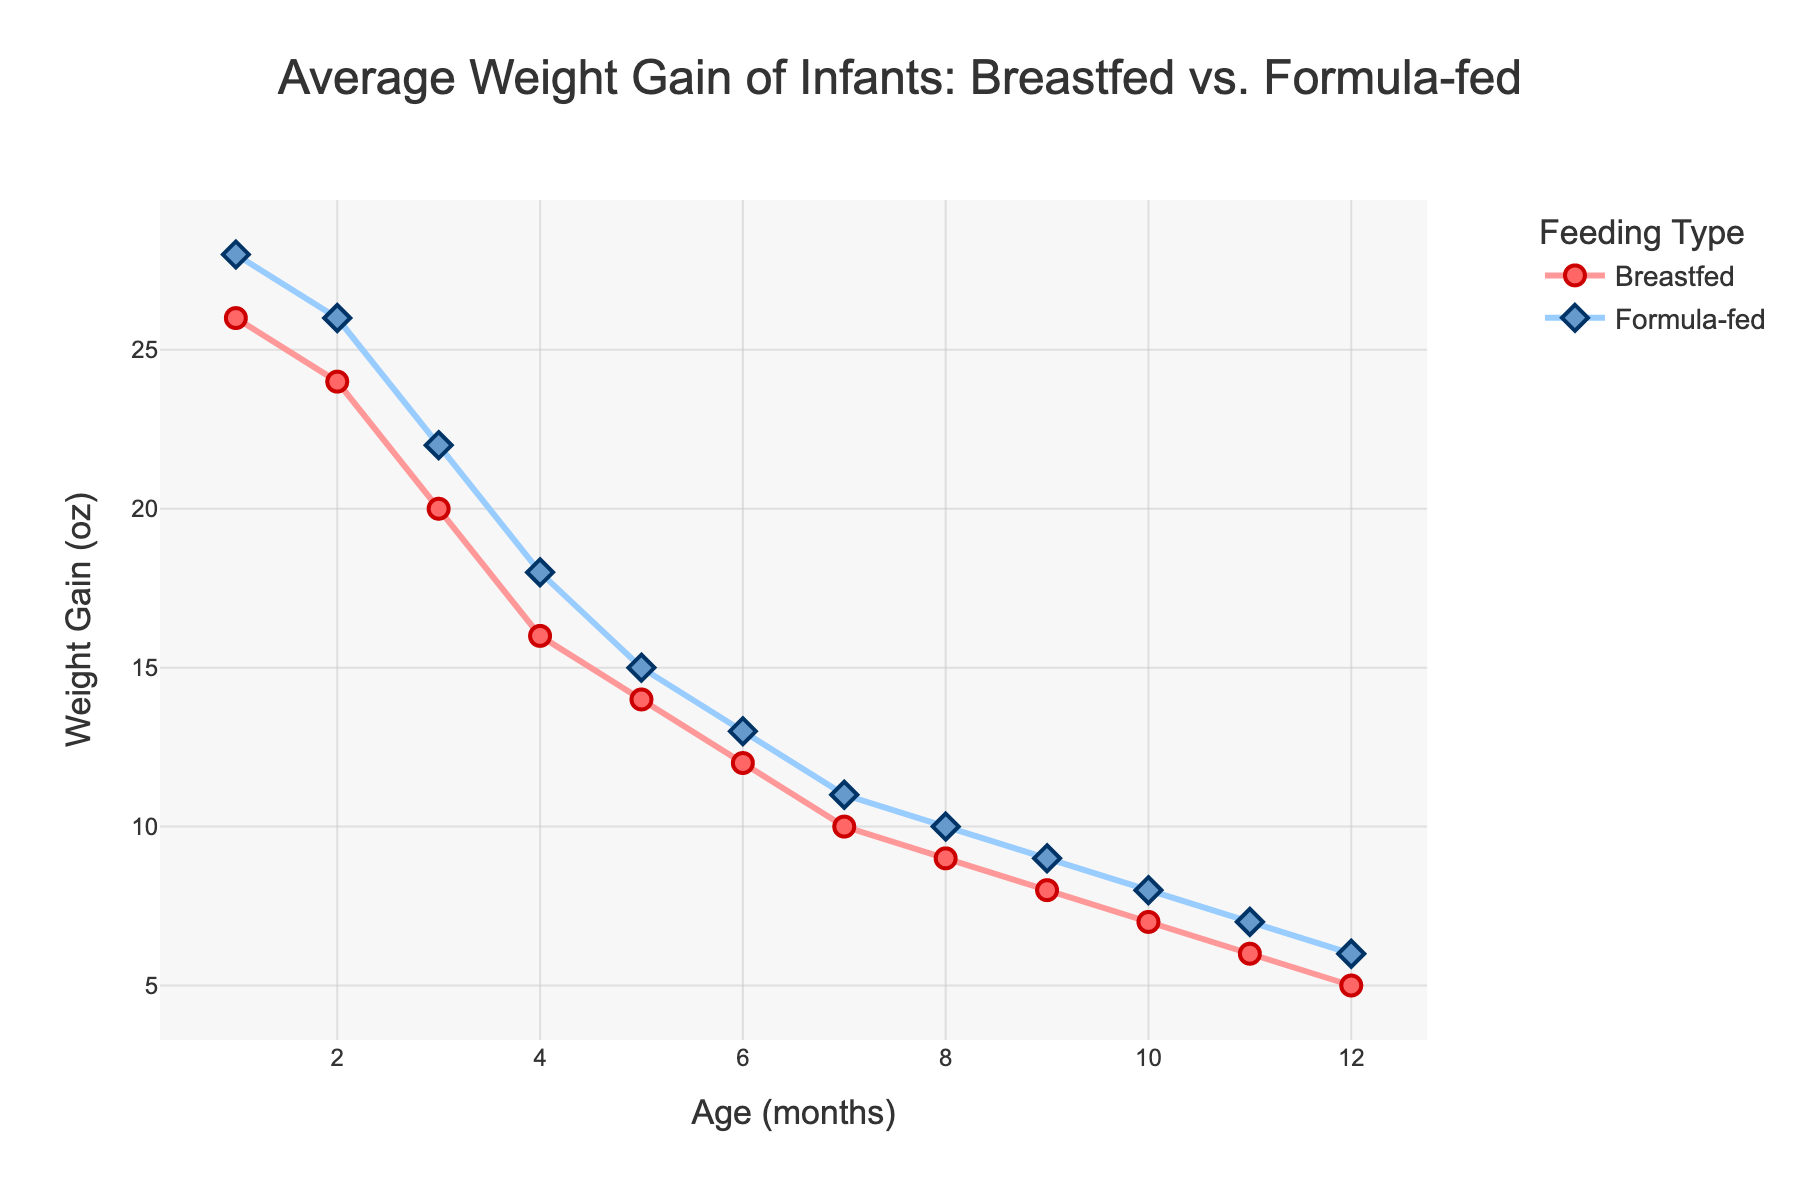What is the weight gain difference between breastfed and formula-fed babies at 6 months? At 6 months, the weight gain for breastfed babies is 12 oz and for formula-fed babies it is 13 oz. The difference is calculated as 13 - 12 = 1 oz.
Answer: 1 oz By how much does the weight gain of formula-fed babies decrease from 1 month to 12 months? The weight gain for formula-fed babies at 1 month is 28 oz and at 12 months is 6 oz. The decrease is calculated as 28 - 6 = 22 oz.
Answer: 22 oz Which group shows a more significant decrease in weight gain from 1 month to 12 months: breastfed or formula-fed babies? The weight gain for breastfed babies decreases from 26 oz to 5 oz, a decrease of 21 oz. For formula-fed babies, it decreases from 28 oz to 6 oz, a decrease of 22 oz. Therefore, formula-fed babies show a slightly more significant decrease.
Answer: Formula-fed babies At what age does the weight gain for breastfed babies first fall below 10 oz? Referring to the figure, the weight gain for breastfed babies first falls below 10 oz at 8 months (9 oz).
Answer: 8 months On average, how much weight do formula-fed babies gain per month during the first year? The total weight gain for formula-fed babies over 12 months is \(28 + 26 + 22 + 18 + 15 + 13 + 11 + 10 + 9 + 8 + 7 + 6 = 173\) oz. The average monthly weight gain is \(173 / 12 \approx 14.42\) oz.
Answer: 14.42 oz 